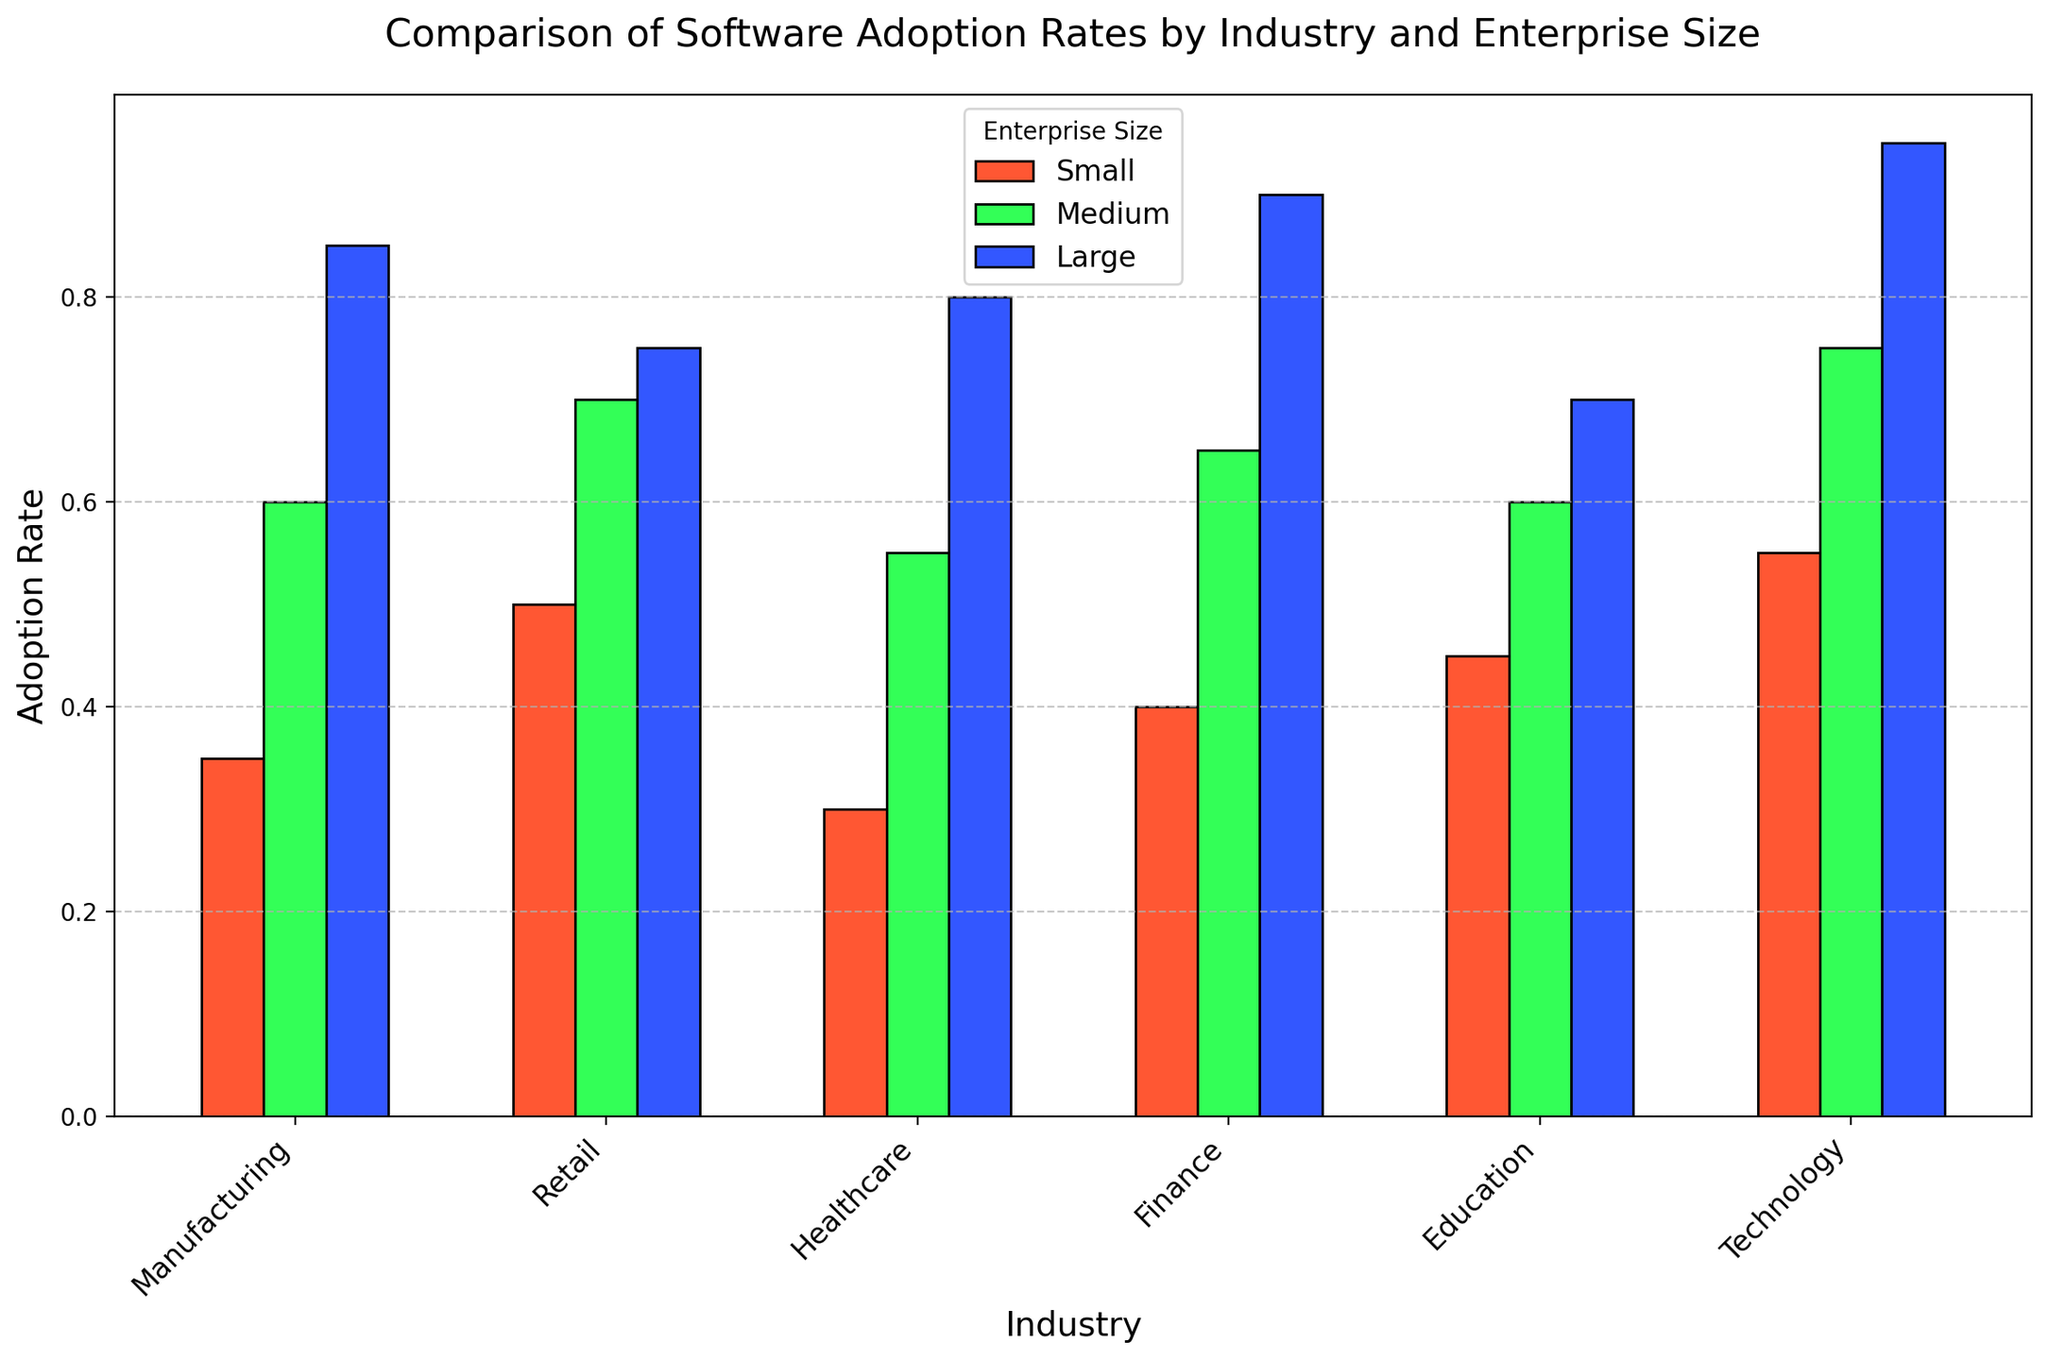Which industry has the highest software adoption rate among large enterprises? By checking the heights of the blue bars (representing large enterprises), we see the highest bar is in the Technology industry.
Answer: Technology Which enterprise size in the Retail industry has the lowest adoption rate? Within the Retail industry section, the shortest bar is the red one, representing small enterprises.
Answer: Small What's the sum of the adoption rates for small enterprises in Manufacturing and Healthcare industries? From the figure, the adoption rates are 0.35 (Manufacturing) and 0.30 (Healthcare). The sum is 0.35 + 0.30.
Answer: 0.65 Compare the software adoption rates between medium and large enterprises in the Finance industry. Which one is greater and by how much? For the Finance industry, the green bar (medium) is at 0.65, and the blue bar (large) is at 0.90. The large enterprises' rate is greater by 0.90 - 0.65.
Answer: Large by 0.25 Which color represents medium enterprises, and what are the adoption rates in the Education industry for these enterprises? The green bars represent medium enterprises. For Education, the height of the green bar indicates an adoption rate of 0.60.
Answer: Green, 0.60 Among medium enterprises, which industry shows the lowest software adoption rate? By scanning the green bars, the shortest one is in the Healthcare industry, indicating the lowest adoption rate among medium enterprises.
Answer: Healthcare What is the average software adoption rate for large enterprises across all industries? Average is obtained by summing all adoption rates for large enterprises across industries and dividing by the total number. (0.85 + 0.75 + 0.80 + 0.90 + 0.70 + 0.95) / 6.
Answer: 0.82 Compare the adoption rates of small enterprises in the Technology and Finance industries. Which one is higher? By looking at the heights of the red bars, Technology (0.55) is higher than Finance (0.40).
Answer: Technology What's the difference in software adoption rates between small and medium enterprises in the Manufacturing industry? The adoption rates are 0.35 for small and 0.60 for medium. The difference is 0.60 - 0.35.
Answer: 0.25 